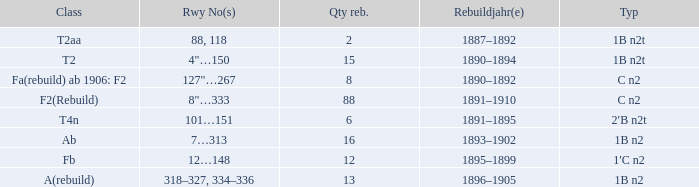What was the Rebuildjahr(e) for the T2AA class? 1887–1892. 